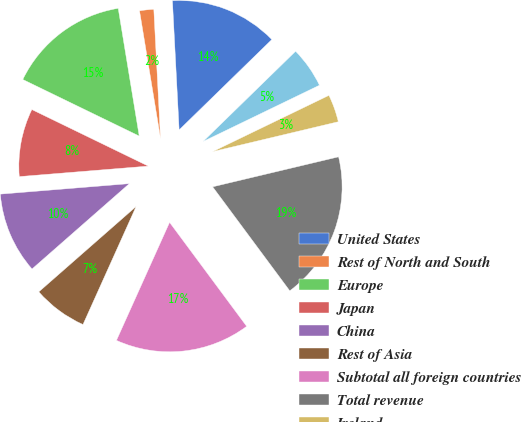<chart> <loc_0><loc_0><loc_500><loc_500><pie_chart><fcel>United States<fcel>Rest of North and South<fcel>Europe<fcel>Japan<fcel>China<fcel>Rest of Asia<fcel>Subtotal all foreign countries<fcel>Total revenue<fcel>Ireland<fcel>Philippines<nl><fcel>13.53%<fcel>1.77%<fcel>15.21%<fcel>8.49%<fcel>10.17%<fcel>6.81%<fcel>16.89%<fcel>18.57%<fcel>3.45%<fcel>5.13%<nl></chart> 